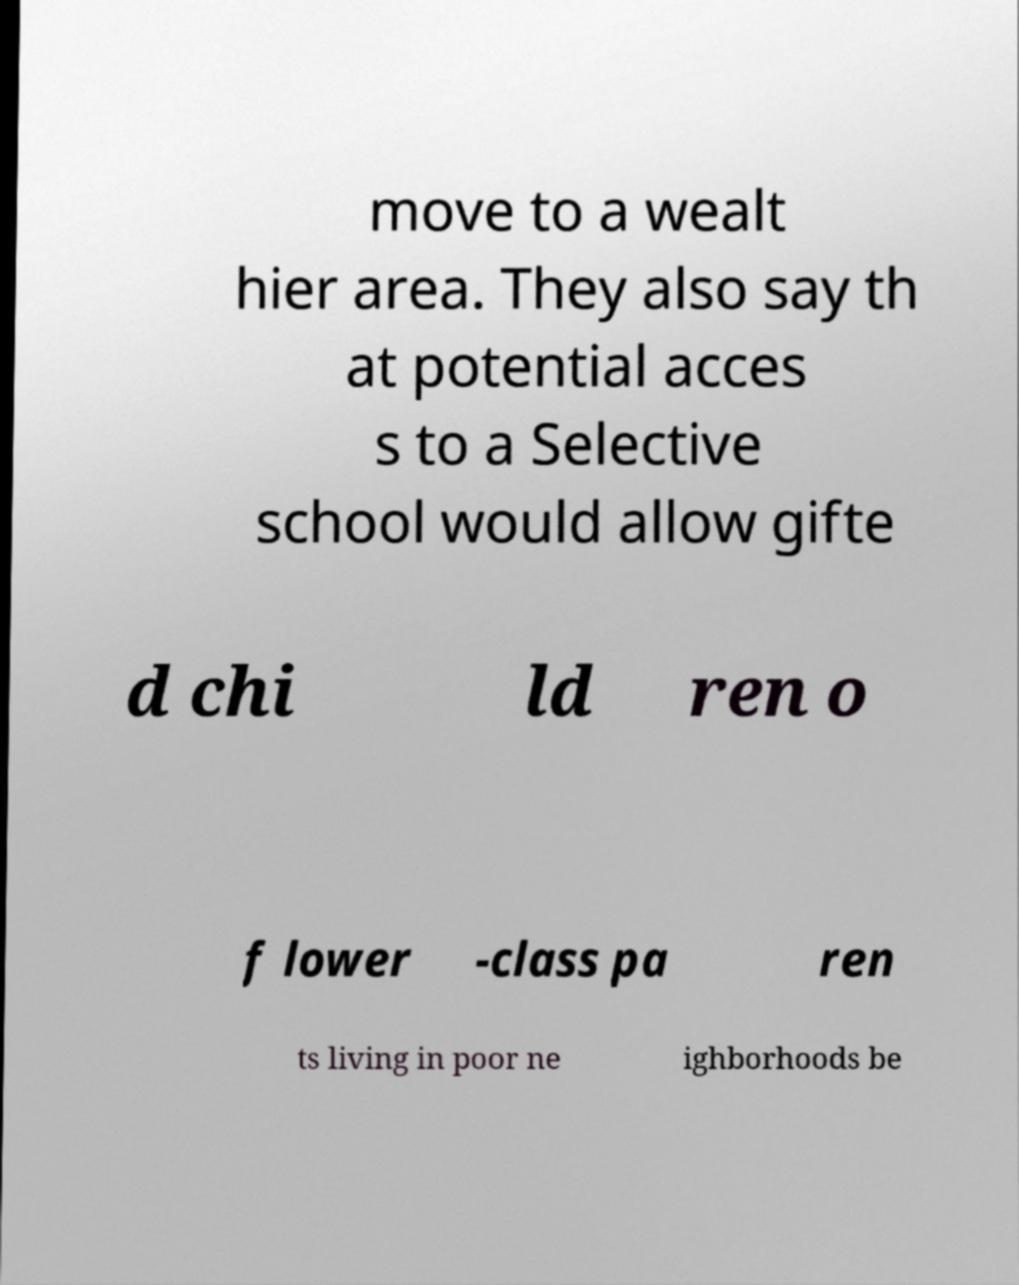For documentation purposes, I need the text within this image transcribed. Could you provide that? move to a wealt hier area. They also say th at potential acces s to a Selective school would allow gifte d chi ld ren o f lower -class pa ren ts living in poor ne ighborhoods be 